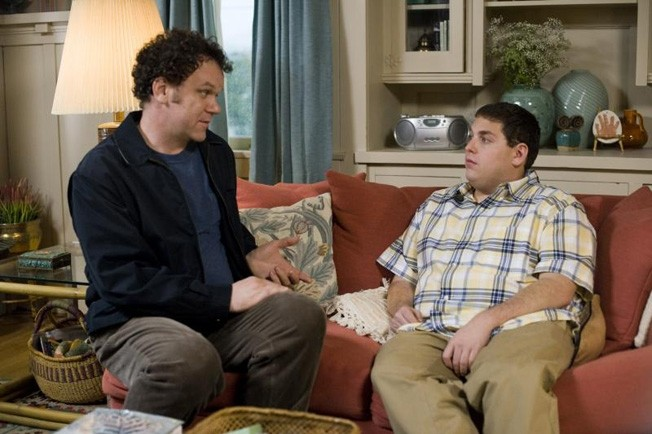Analyze the image in a comprehensive and detailed manner. The image shows actors John C. Reilly and Jonah Hill engaged in an intimate and possibly tense conversation. John C. Reilly, wearing a blue shirt under a black jacket, is seated comfortably on a red couch. Jonah Hill, in a yellow and white striped shirt, rests on the arm of the couch, facing Reilly. Their postures and intense facial expressions suggest a crucial moment of emotional or psychological exchange in the narrative of the film 'Cyrus'. The living room setting, characterized by its warm colors, cozy furnishings, and personal decor items like books and a shell collection, reflects a domestic sphere that could be central to the themes of personal and relational conflict portrayed in the movie. This enhances the scene's emotional weight, inviting viewers to ponder the complexities of the characters' relationship. 